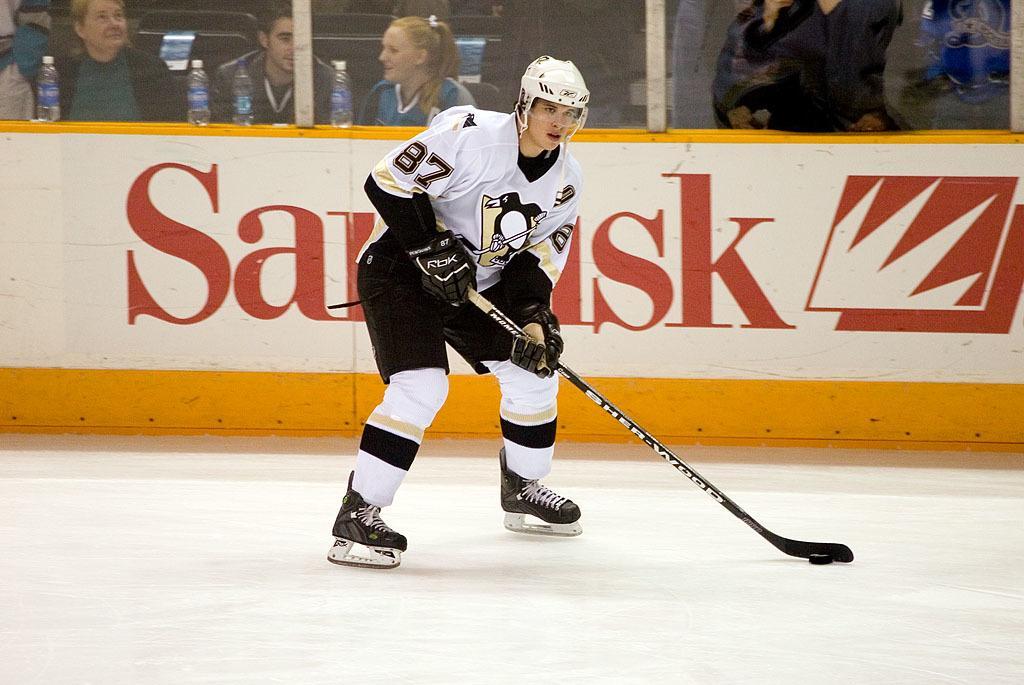Can you describe this image briefly? There is a man playing hockey. There is a hockey stick in his hand. In the background there are people. A bottle is placed on the wall. 